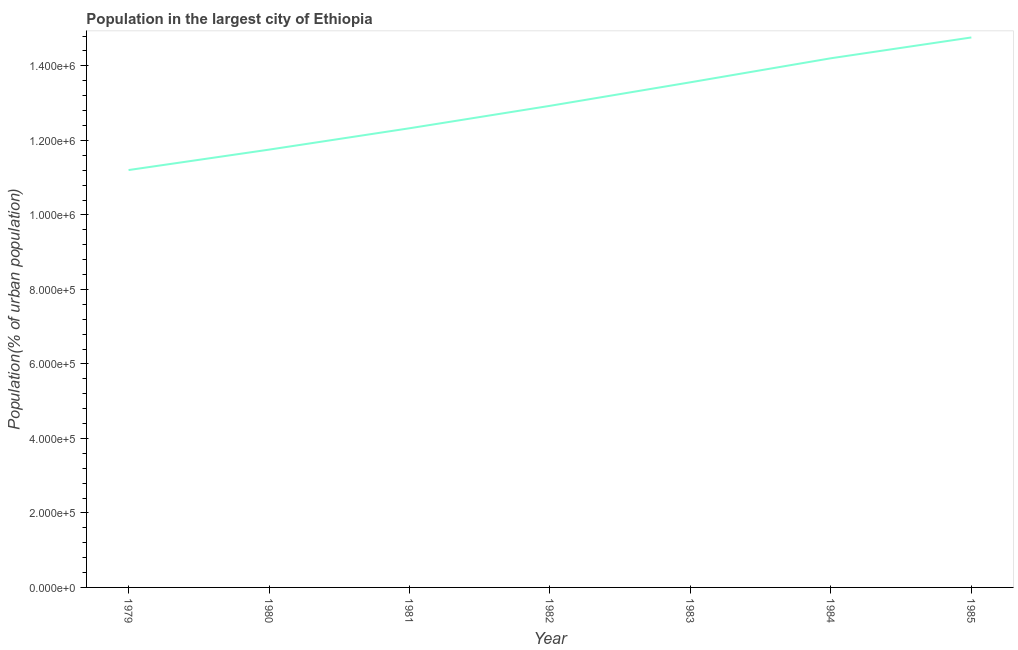What is the population in largest city in 1983?
Offer a very short reply. 1.36e+06. Across all years, what is the maximum population in largest city?
Keep it short and to the point. 1.48e+06. Across all years, what is the minimum population in largest city?
Offer a terse response. 1.12e+06. In which year was the population in largest city maximum?
Offer a very short reply. 1985. In which year was the population in largest city minimum?
Provide a succinct answer. 1979. What is the sum of the population in largest city?
Provide a short and direct response. 9.07e+06. What is the difference between the population in largest city in 1980 and 1982?
Ensure brevity in your answer.  -1.18e+05. What is the average population in largest city per year?
Your answer should be very brief. 1.30e+06. What is the median population in largest city?
Provide a short and direct response. 1.29e+06. In how many years, is the population in largest city greater than 1000000 %?
Your answer should be compact. 7. What is the ratio of the population in largest city in 1979 to that in 1982?
Your answer should be very brief. 0.87. Is the population in largest city in 1981 less than that in 1984?
Keep it short and to the point. Yes. What is the difference between the highest and the second highest population in largest city?
Keep it short and to the point. 5.59e+04. What is the difference between the highest and the lowest population in largest city?
Make the answer very short. 3.56e+05. In how many years, is the population in largest city greater than the average population in largest city taken over all years?
Your answer should be compact. 3. How many years are there in the graph?
Your answer should be very brief. 7. What is the difference between two consecutive major ticks on the Y-axis?
Ensure brevity in your answer.  2.00e+05. What is the title of the graph?
Offer a very short reply. Population in the largest city of Ethiopia. What is the label or title of the Y-axis?
Provide a succinct answer. Population(% of urban population). What is the Population(% of urban population) of 1979?
Provide a short and direct response. 1.12e+06. What is the Population(% of urban population) of 1980?
Make the answer very short. 1.18e+06. What is the Population(% of urban population) of 1981?
Your answer should be very brief. 1.23e+06. What is the Population(% of urban population) of 1982?
Ensure brevity in your answer.  1.29e+06. What is the Population(% of urban population) in 1983?
Your response must be concise. 1.36e+06. What is the Population(% of urban population) in 1984?
Provide a short and direct response. 1.42e+06. What is the Population(% of urban population) of 1985?
Offer a terse response. 1.48e+06. What is the difference between the Population(% of urban population) in 1979 and 1980?
Provide a short and direct response. -5.48e+04. What is the difference between the Population(% of urban population) in 1979 and 1981?
Provide a succinct answer. -1.12e+05. What is the difference between the Population(% of urban population) in 1979 and 1982?
Ensure brevity in your answer.  -1.72e+05. What is the difference between the Population(% of urban population) in 1979 and 1983?
Provide a succinct answer. -2.36e+05. What is the difference between the Population(% of urban population) in 1979 and 1984?
Give a very brief answer. -3.00e+05. What is the difference between the Population(% of urban population) in 1979 and 1985?
Provide a short and direct response. -3.56e+05. What is the difference between the Population(% of urban population) in 1980 and 1981?
Your response must be concise. -5.74e+04. What is the difference between the Population(% of urban population) in 1980 and 1982?
Ensure brevity in your answer.  -1.18e+05. What is the difference between the Population(% of urban population) in 1980 and 1983?
Your response must be concise. -1.81e+05. What is the difference between the Population(% of urban population) in 1980 and 1984?
Keep it short and to the point. -2.45e+05. What is the difference between the Population(% of urban population) in 1980 and 1985?
Your answer should be very brief. -3.01e+05. What is the difference between the Population(% of urban population) in 1981 and 1982?
Give a very brief answer. -6.02e+04. What is the difference between the Population(% of urban population) in 1981 and 1983?
Give a very brief answer. -1.23e+05. What is the difference between the Population(% of urban population) in 1981 and 1984?
Offer a very short reply. -1.88e+05. What is the difference between the Population(% of urban population) in 1981 and 1985?
Provide a short and direct response. -2.44e+05. What is the difference between the Population(% of urban population) in 1982 and 1983?
Your answer should be very brief. -6.32e+04. What is the difference between the Population(% of urban population) in 1982 and 1984?
Keep it short and to the point. -1.28e+05. What is the difference between the Population(% of urban population) in 1982 and 1985?
Provide a short and direct response. -1.84e+05. What is the difference between the Population(% of urban population) in 1983 and 1984?
Make the answer very short. -6.45e+04. What is the difference between the Population(% of urban population) in 1983 and 1985?
Your answer should be very brief. -1.20e+05. What is the difference between the Population(% of urban population) in 1984 and 1985?
Offer a terse response. -5.59e+04. What is the ratio of the Population(% of urban population) in 1979 to that in 1980?
Offer a very short reply. 0.95. What is the ratio of the Population(% of urban population) in 1979 to that in 1981?
Make the answer very short. 0.91. What is the ratio of the Population(% of urban population) in 1979 to that in 1982?
Ensure brevity in your answer.  0.87. What is the ratio of the Population(% of urban population) in 1979 to that in 1983?
Your answer should be compact. 0.83. What is the ratio of the Population(% of urban population) in 1979 to that in 1984?
Your response must be concise. 0.79. What is the ratio of the Population(% of urban population) in 1979 to that in 1985?
Offer a terse response. 0.76. What is the ratio of the Population(% of urban population) in 1980 to that in 1981?
Ensure brevity in your answer.  0.95. What is the ratio of the Population(% of urban population) in 1980 to that in 1982?
Your response must be concise. 0.91. What is the ratio of the Population(% of urban population) in 1980 to that in 1983?
Make the answer very short. 0.87. What is the ratio of the Population(% of urban population) in 1980 to that in 1984?
Provide a short and direct response. 0.83. What is the ratio of the Population(% of urban population) in 1980 to that in 1985?
Offer a terse response. 0.8. What is the ratio of the Population(% of urban population) in 1981 to that in 1982?
Your answer should be very brief. 0.95. What is the ratio of the Population(% of urban population) in 1981 to that in 1983?
Give a very brief answer. 0.91. What is the ratio of the Population(% of urban population) in 1981 to that in 1984?
Provide a short and direct response. 0.87. What is the ratio of the Population(% of urban population) in 1981 to that in 1985?
Your response must be concise. 0.83. What is the ratio of the Population(% of urban population) in 1982 to that in 1983?
Keep it short and to the point. 0.95. What is the ratio of the Population(% of urban population) in 1982 to that in 1984?
Offer a terse response. 0.91. What is the ratio of the Population(% of urban population) in 1982 to that in 1985?
Your response must be concise. 0.88. What is the ratio of the Population(% of urban population) in 1983 to that in 1984?
Offer a very short reply. 0.95. What is the ratio of the Population(% of urban population) in 1983 to that in 1985?
Offer a very short reply. 0.92. 